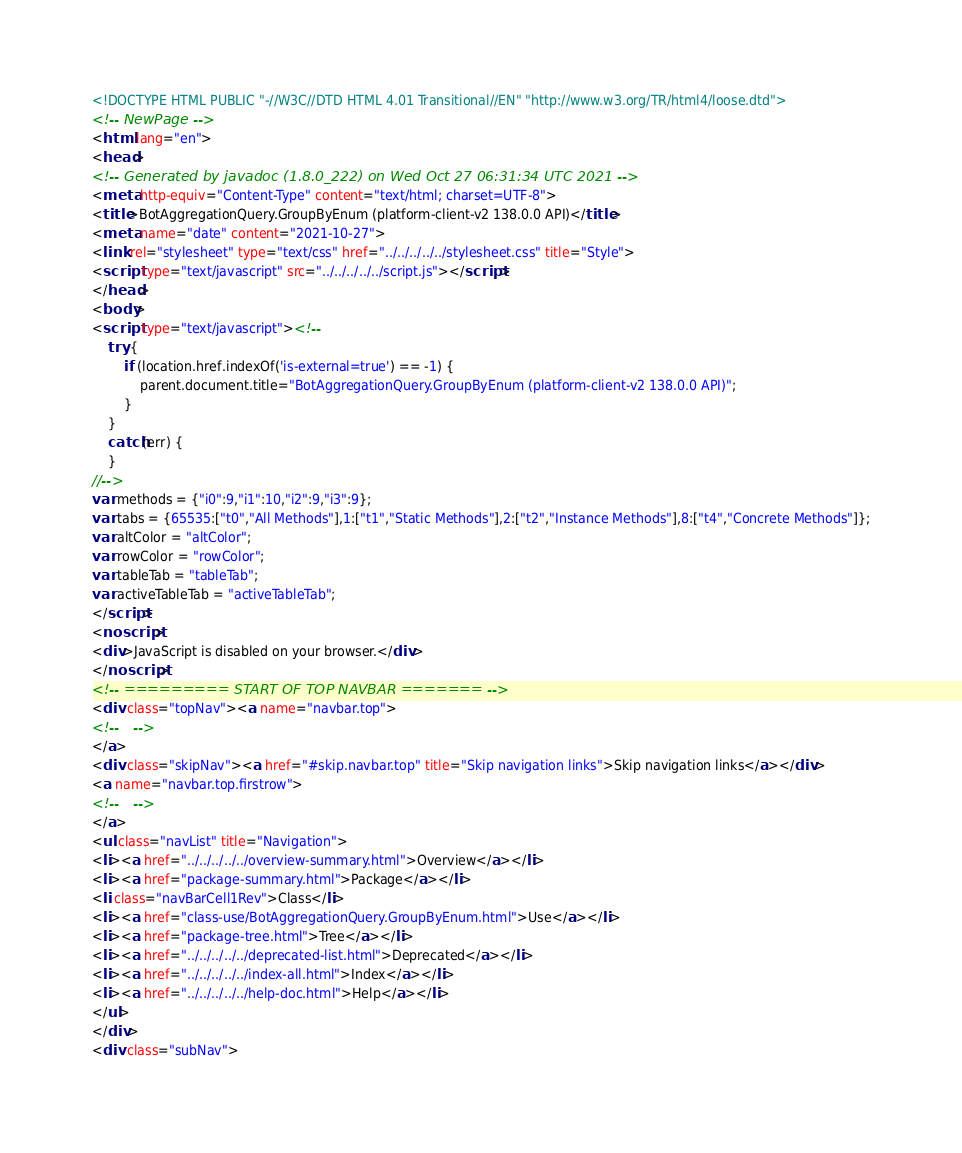Convert code to text. <code><loc_0><loc_0><loc_500><loc_500><_HTML_><!DOCTYPE HTML PUBLIC "-//W3C//DTD HTML 4.01 Transitional//EN" "http://www.w3.org/TR/html4/loose.dtd">
<!-- NewPage -->
<html lang="en">
<head>
<!-- Generated by javadoc (1.8.0_222) on Wed Oct 27 06:31:34 UTC 2021 -->
<meta http-equiv="Content-Type" content="text/html; charset=UTF-8">
<title>BotAggregationQuery.GroupByEnum (platform-client-v2 138.0.0 API)</title>
<meta name="date" content="2021-10-27">
<link rel="stylesheet" type="text/css" href="../../../../../stylesheet.css" title="Style">
<script type="text/javascript" src="../../../../../script.js"></script>
</head>
<body>
<script type="text/javascript"><!--
    try {
        if (location.href.indexOf('is-external=true') == -1) {
            parent.document.title="BotAggregationQuery.GroupByEnum (platform-client-v2 138.0.0 API)";
        }
    }
    catch(err) {
    }
//-->
var methods = {"i0":9,"i1":10,"i2":9,"i3":9};
var tabs = {65535:["t0","All Methods"],1:["t1","Static Methods"],2:["t2","Instance Methods"],8:["t4","Concrete Methods"]};
var altColor = "altColor";
var rowColor = "rowColor";
var tableTab = "tableTab";
var activeTableTab = "activeTableTab";
</script>
<noscript>
<div>JavaScript is disabled on your browser.</div>
</noscript>
<!-- ========= START OF TOP NAVBAR ======= -->
<div class="topNav"><a name="navbar.top">
<!--   -->
</a>
<div class="skipNav"><a href="#skip.navbar.top" title="Skip navigation links">Skip navigation links</a></div>
<a name="navbar.top.firstrow">
<!--   -->
</a>
<ul class="navList" title="Navigation">
<li><a href="../../../../../overview-summary.html">Overview</a></li>
<li><a href="package-summary.html">Package</a></li>
<li class="navBarCell1Rev">Class</li>
<li><a href="class-use/BotAggregationQuery.GroupByEnum.html">Use</a></li>
<li><a href="package-tree.html">Tree</a></li>
<li><a href="../../../../../deprecated-list.html">Deprecated</a></li>
<li><a href="../../../../../index-all.html">Index</a></li>
<li><a href="../../../../../help-doc.html">Help</a></li>
</ul>
</div>
<div class="subNav"></code> 